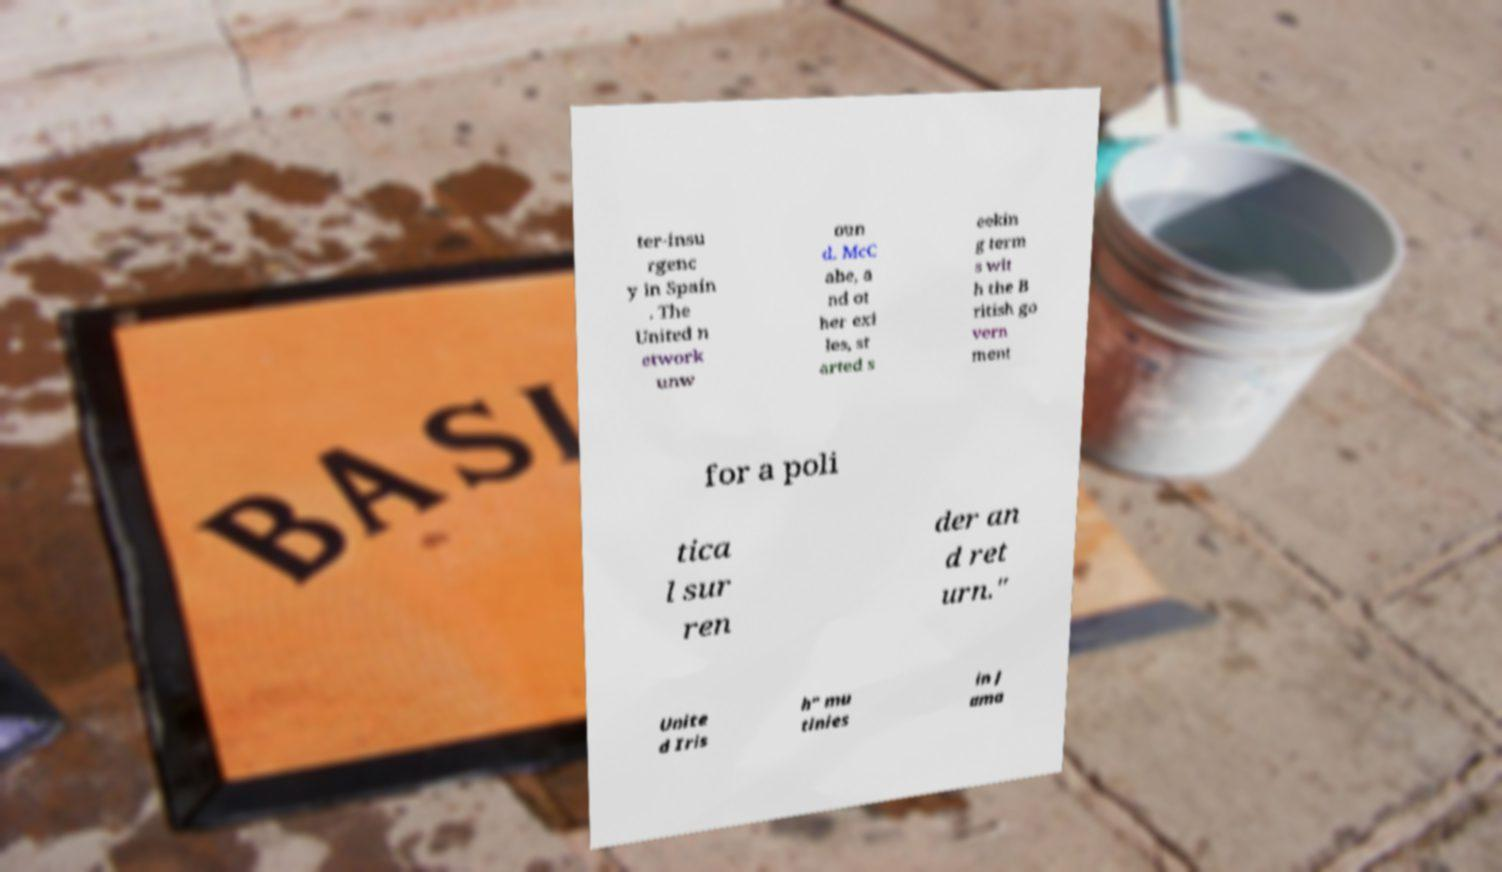Could you assist in decoding the text presented in this image and type it out clearly? ter-insu rgenc y in Spain . The United n etwork unw oun d. McC abe, a nd ot her exi les, st arted s eekin g term s wit h the B ritish go vern ment for a poli tica l sur ren der an d ret urn." Unite d Iris h" mu tinies in J ama 